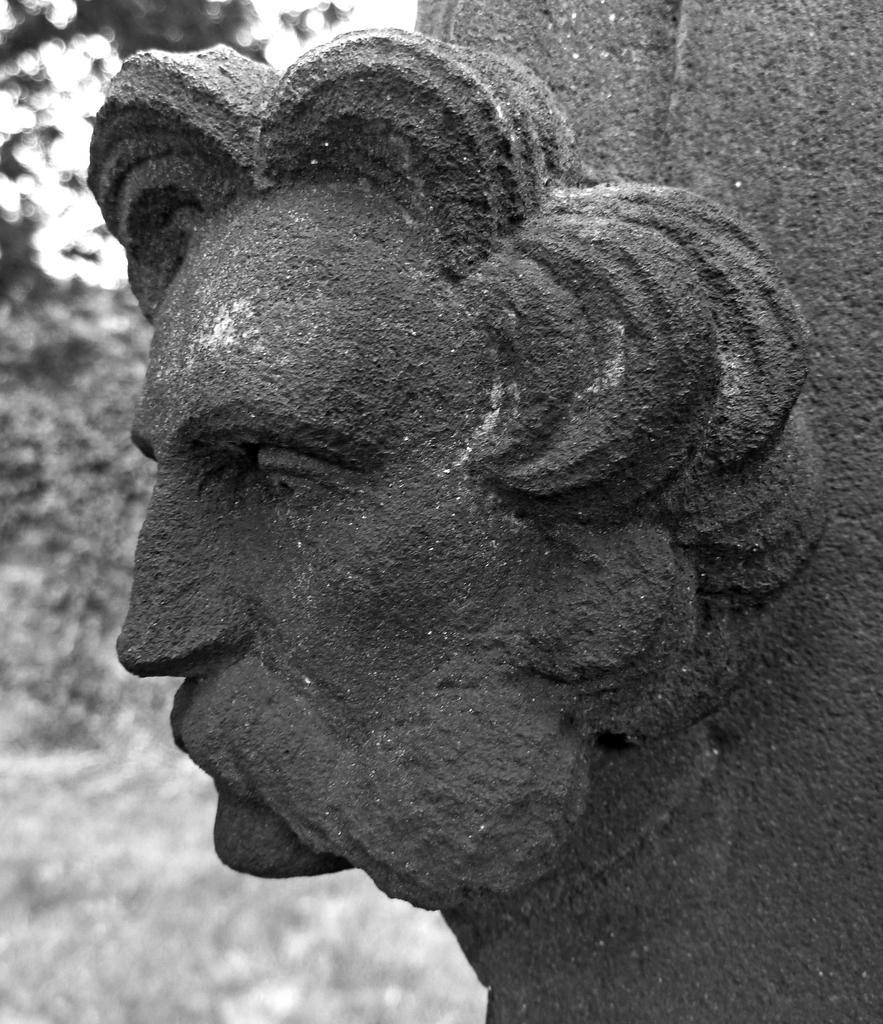Describe this image in one or two sentences. In this image I can see a sculpture. In the background there are some trees. At the bottom, I can see the ground. This is a black and white image. 